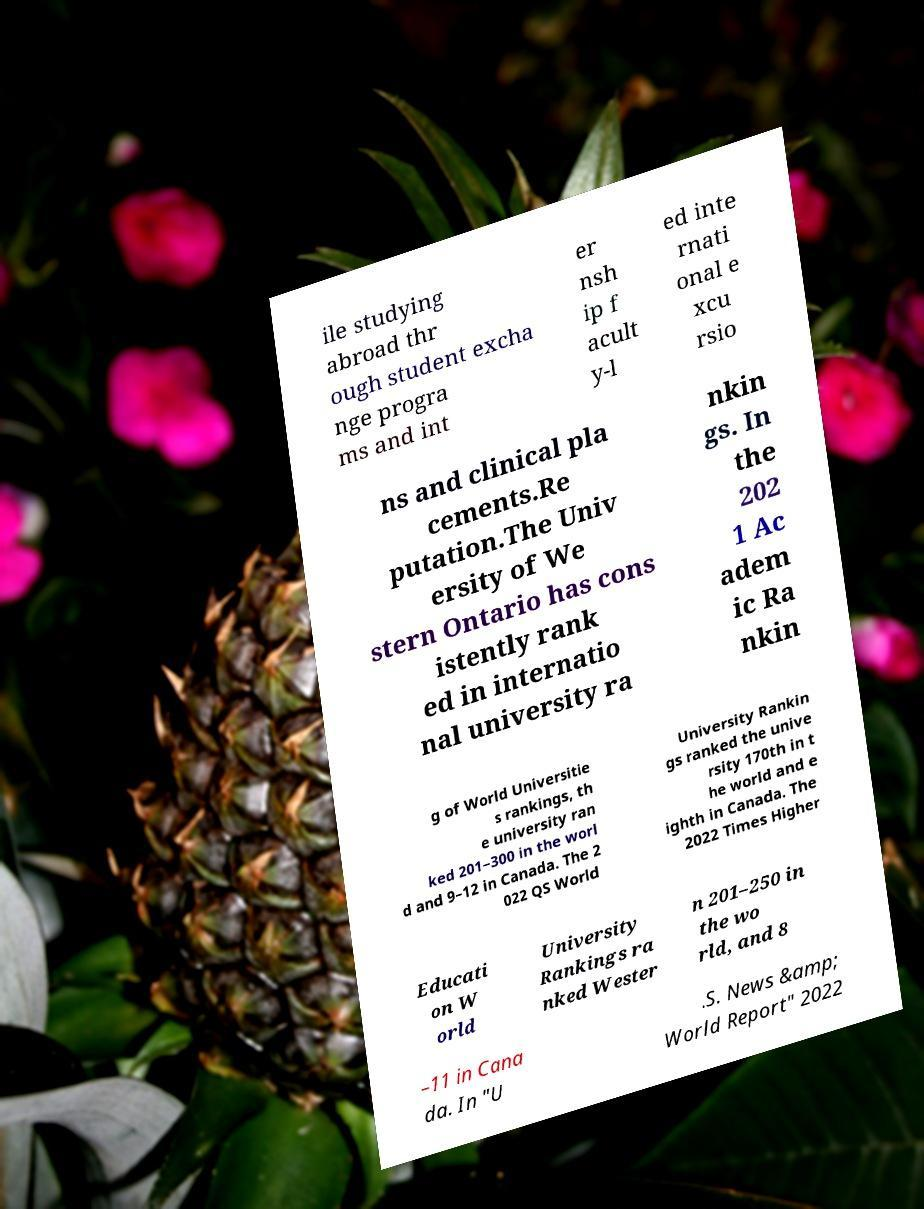Can you accurately transcribe the text from the provided image for me? ile studying abroad thr ough student excha nge progra ms and int er nsh ip f acult y-l ed inte rnati onal e xcu rsio ns and clinical pla cements.Re putation.The Univ ersity of We stern Ontario has cons istently rank ed in internatio nal university ra nkin gs. In the 202 1 Ac adem ic Ra nkin g of World Universitie s rankings, th e university ran ked 201–300 in the worl d and 9–12 in Canada. The 2 022 QS World University Rankin gs ranked the unive rsity 170th in t he world and e ighth in Canada. The 2022 Times Higher Educati on W orld University Rankings ra nked Wester n 201–250 in the wo rld, and 8 –11 in Cana da. In "U .S. News &amp; World Report" 2022 